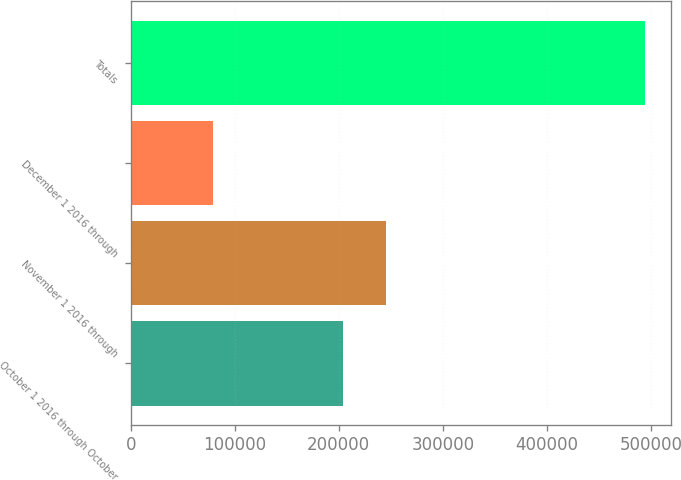Convert chart to OTSL. <chart><loc_0><loc_0><loc_500><loc_500><bar_chart><fcel>October 1 2016 through October<fcel>November 1 2016 through<fcel>December 1 2016 through<fcel>Totals<nl><fcel>204350<fcel>245892<fcel>79435<fcel>494856<nl></chart> 